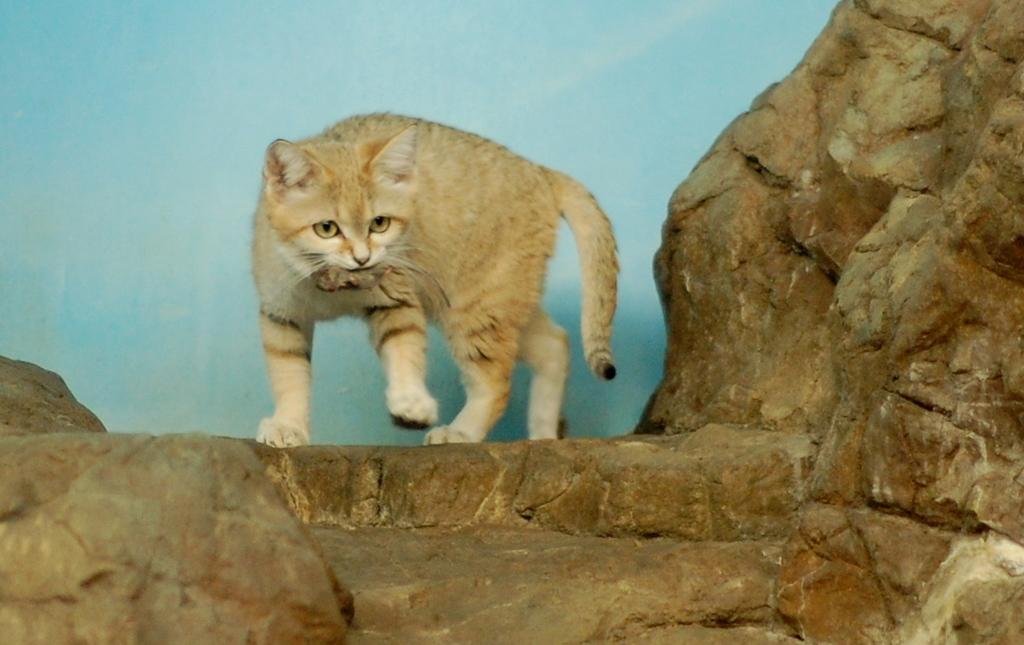What type of animal is in the image? There is a brown color cat in the image. Where is the cat positioned in the image? The cat is standing on a rock. What is the cat doing in the image? The cat is looking into the camera. What color is the background in the image? There is a blue background in the image. Can you tell me how many beetles are crawling on the cat in the image? There are no beetles present in the image; it features a brown color cat standing on a rock and looking into the camera. Is there a fireman visiting the cat in the image? There is no fireman or any other person present in the image; it only features a brown color cat standing on a rock and looking into the camera. 